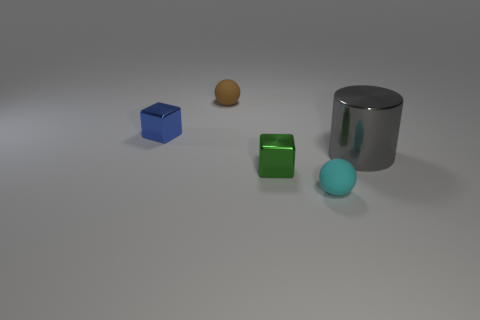Is the size of the cyan matte sphere the same as the gray cylinder?
Offer a very short reply. No. Is the material of the small sphere that is in front of the large gray object the same as the big gray thing?
Offer a very short reply. No. What number of tiny green blocks are left of the matte ball that is left of the sphere that is on the right side of the small green shiny thing?
Provide a succinct answer. 0. Do the small cyan rubber thing in front of the green metallic cube and the brown rubber thing have the same shape?
Ensure brevity in your answer.  Yes. How many things are cyan matte blocks or matte objects that are on the right side of the tiny brown rubber object?
Give a very brief answer. 1. Are there more tiny brown matte spheres that are left of the big metal thing than large brown cylinders?
Provide a short and direct response. Yes. Are there an equal number of gray metallic cylinders that are on the left side of the gray metallic cylinder and shiny blocks that are right of the brown matte sphere?
Make the answer very short. No. Is there a small shiny block that is left of the gray cylinder that is in front of the blue metallic cube?
Your response must be concise. Yes. What is the shape of the small cyan thing?
Keep it short and to the point. Sphere. There is a metal cylinder to the right of the tiny shiny thing that is behind the green cube; what size is it?
Ensure brevity in your answer.  Large. 